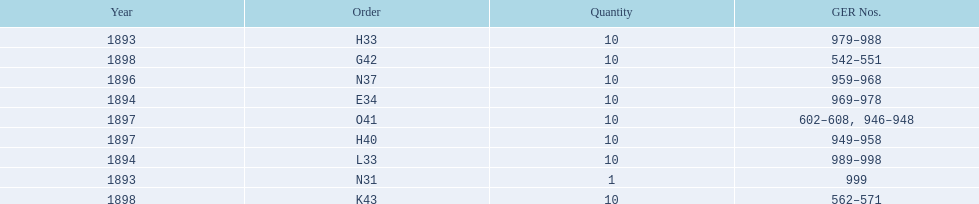What is the duration of the time span in years? 5 years. Give me the full table as a dictionary. {'header': ['Year', 'Order', 'Quantity', 'GER Nos.'], 'rows': [['1893', 'H33', '10', '979–988'], ['1898', 'G42', '10', '542–551'], ['1896', 'N37', '10', '959–968'], ['1894', 'E34', '10', '969–978'], ['1897', 'O41', '10', '602–608, 946–948'], ['1897', 'H40', '10', '949–958'], ['1894', 'L33', '10', '989–998'], ['1893', 'N31', '1', '999'], ['1898', 'K43', '10', '562–571']]} 